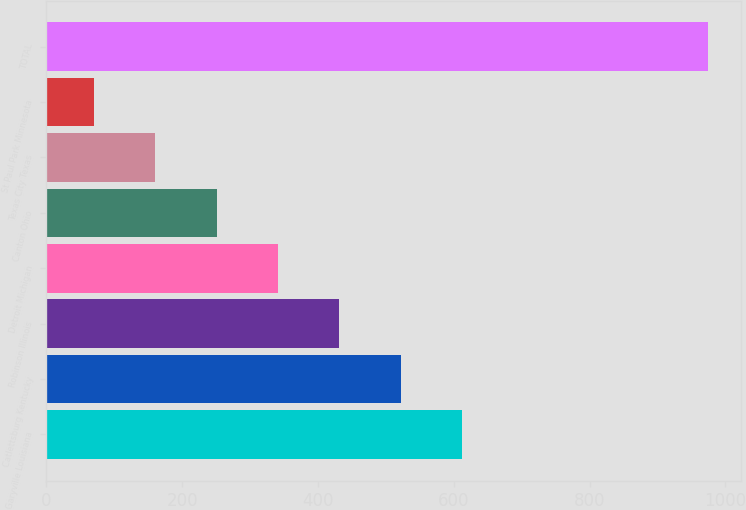<chart> <loc_0><loc_0><loc_500><loc_500><bar_chart><fcel>Garyville Louisiana<fcel>Catlettsburg Kentucky<fcel>Robinson Illinois<fcel>Detroit Michigan<fcel>Canton Ohio<fcel>Texas City Texas<fcel>St Paul Park Minnesota<fcel>TOTAL<nl><fcel>612.4<fcel>522<fcel>431.6<fcel>341.2<fcel>250.8<fcel>160.4<fcel>70<fcel>974<nl></chart> 